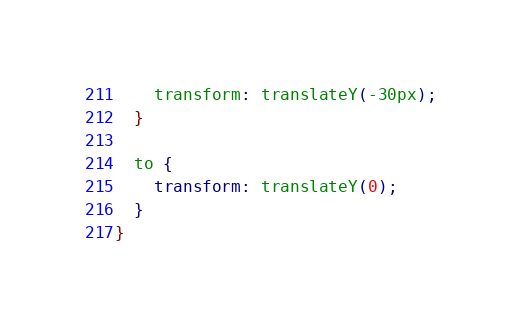Convert code to text. <code><loc_0><loc_0><loc_500><loc_500><_CSS_>    transform: translateY(-30px);
  }

  to {
    transform: translateY(0);
  }
}

</code> 